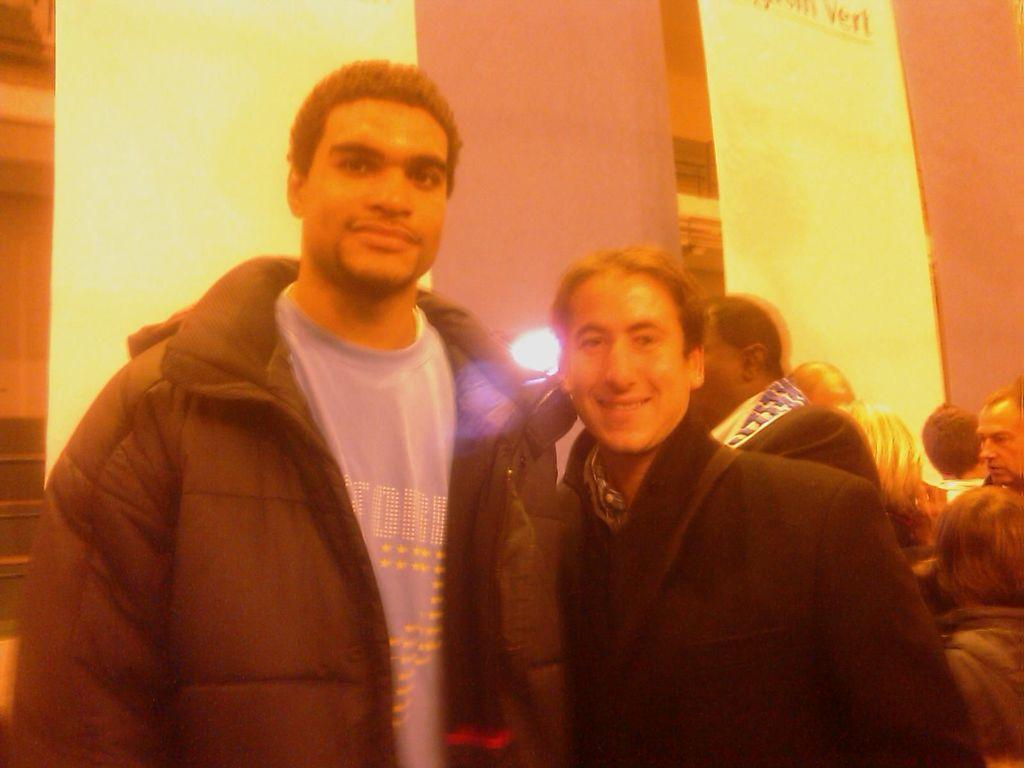How many men are present in the image? There are two men standing in the image. Can you describe the background of the image? There are few persons in the background of the image, along with hoardings and a wall. What type of quartz can be seen on the wall in the image? There is no quartz present in the image; the wall is not described as having any quartz. 